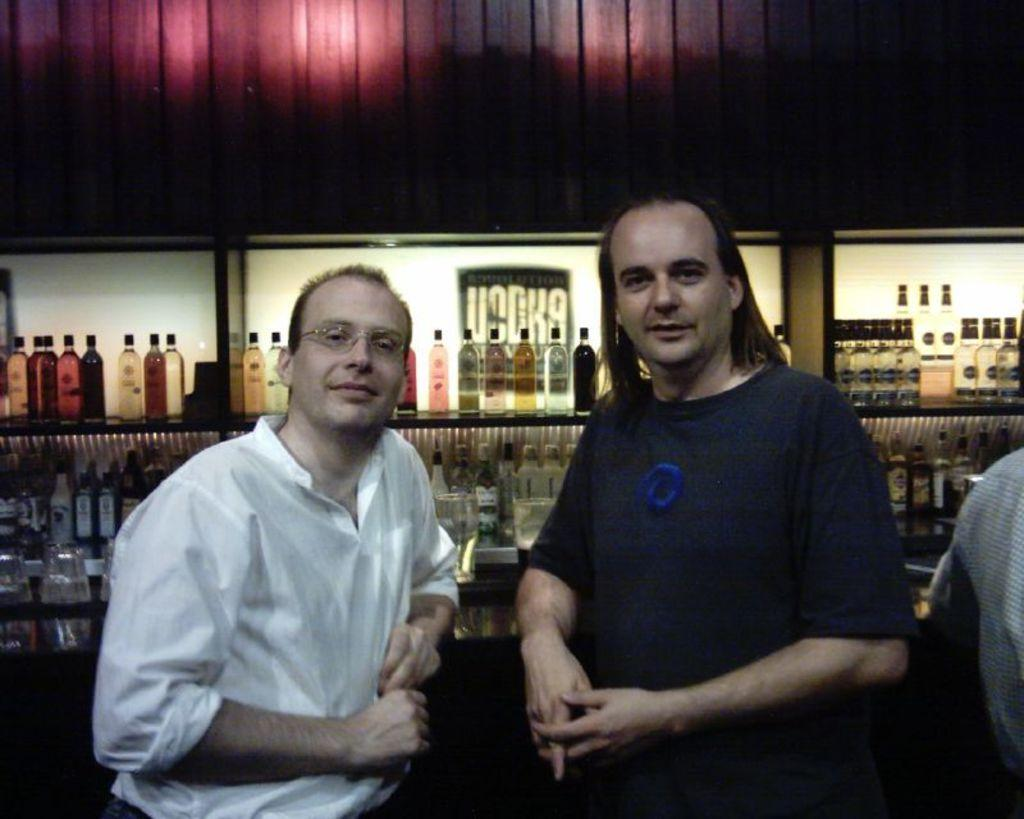How many people are present in the image? There are two persons standing in the image. Where are the persons located in the image? The persons are at the bottom of the image. What can be seen in the background of the image? There are bottles kept in racks in the background of the image. How many houses can be seen on the border in the image? There are no houses or borders present in the image; it features two persons standing and bottles kept in racks in the background. 